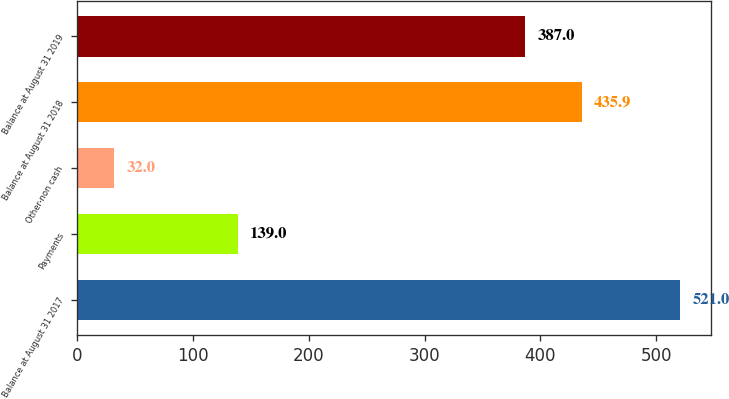Convert chart to OTSL. <chart><loc_0><loc_0><loc_500><loc_500><bar_chart><fcel>Balance at August 31 2017<fcel>Payments<fcel>Other-non cash<fcel>Balance at August 31 2018<fcel>Balance at August 31 2019<nl><fcel>521<fcel>139<fcel>32<fcel>435.9<fcel>387<nl></chart> 